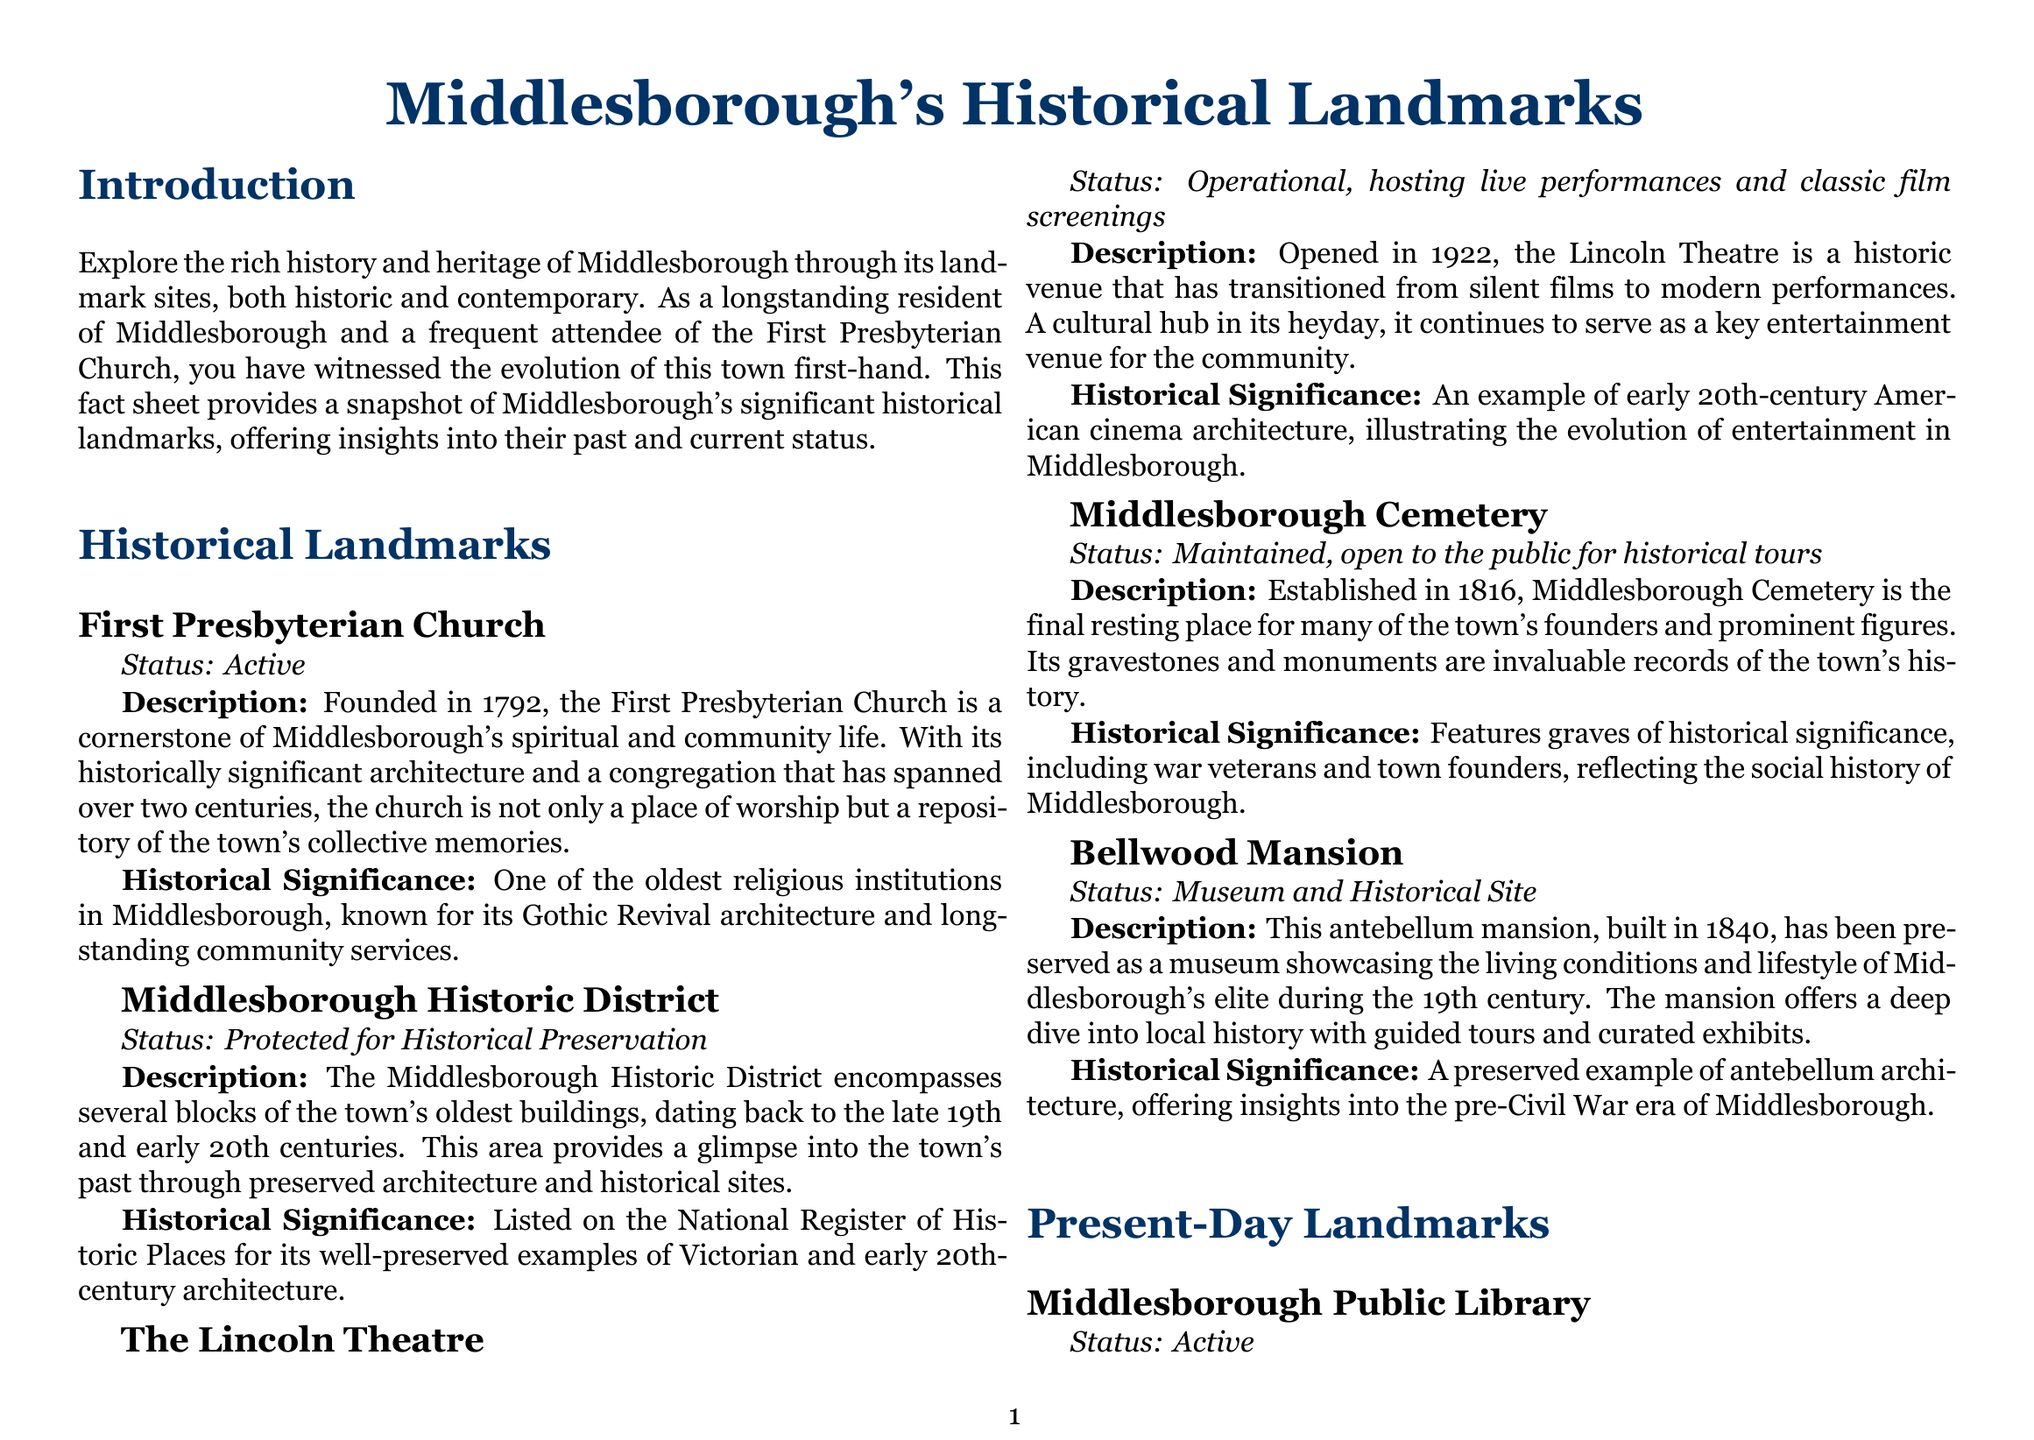What year was the First Presbyterian Church founded? The founding year of the First Presbyterian Church is mentioned in the document.
Answer: 1792 How many years has Middlesborough Public Library been serving the community as of now? The library was founded in 1903, and the current year is 2023, so the calculation is 2023 - 1903.
Answer: 120 years What is the status of the Middlesborough Historic District? The status of this historical district is specified in the document.
Answer: Protected for Historical Preservation What architectural style is the First Presbyterian Church known for? The document mentions its architectural style.
Answer: Gothic Revival architecture What is the purpose of the Middlesborough Cemetery? The document describes the significance of the cemetery.
Answer: Final resting place What type of tours does Bellwood Mansion offer? The document states the type of visits available at the mansion.
Answer: Guided tours Which organization funded Middlesborough Public Library? The document specifies the foundation that supported the library's establishment.
Answer: Carnegie Foundation What is the historical significance of Cumberland Gap National Historical Park? The document discusses the park's importance in American history.
Answer: Crucial during the westward expansion of the United States What was the original opening year of The Lincoln Theatre? The document provides the initial opening year of the theatre.
Answer: 1922 